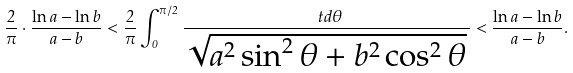Convert formula to latex. <formula><loc_0><loc_0><loc_500><loc_500>\frac { 2 } { \pi } \cdot \frac { \ln a - \ln b } { a - b } < \frac { 2 } { \pi } \int _ { 0 } ^ { \pi / 2 } \frac { \ t d \theta } { \sqrt { a ^ { 2 } \sin ^ { 2 } \theta + b ^ { 2 } \cos ^ { 2 } \theta } \, } < \frac { \ln a - \ln b } { a - b } .</formula> 